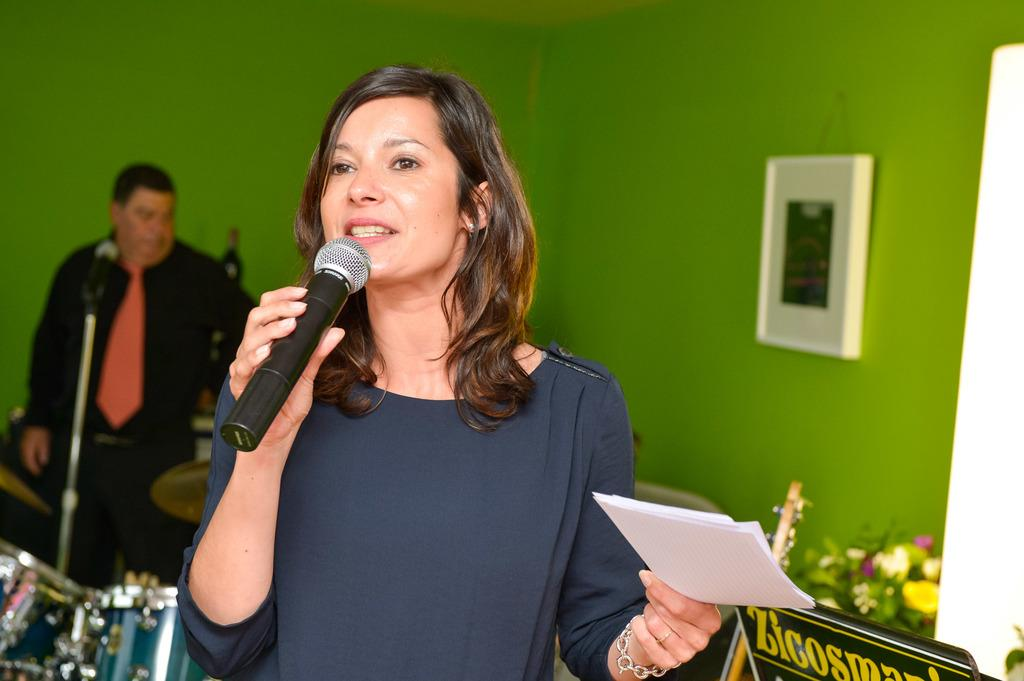What is the person in the image holding? The person is holding a microphone and a paper. What can be seen in the background of the image? There is a wall, another person, and a musical instrument in the background of the image. What might the person holding the microphone be doing? The person holding the microphone might be giving a speech or performing. Can you describe the musical instrument in the background? Unfortunately, the facts provided do not give a specific description of the musical instrument. Reasoning: Let's think step by step by step in order to produce the conversation. We start by identifying the main subject in the image, which is the person holding a microphone and a paper. Then, we expand the conversation to include other details about the image, such as the background and the presence of another person and a musical instrument. Each question is designed to elicit a specific detail about the image that is known from the provided facts. Absurd Question/Answer: What type of orange is being used as a prop in the image? There is no orange present in the image. 